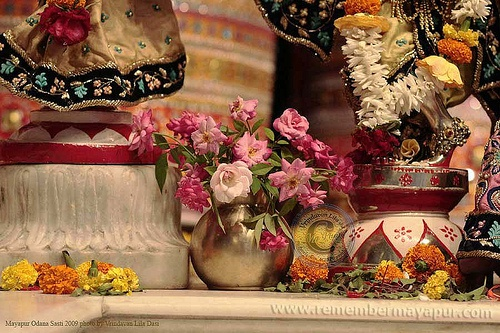Describe the objects in this image and their specific colors. I can see potted plant in maroon, brown, black, and salmon tones, vase in maroon, black, tan, and gray tones, and vase in maroon, tan, and gray tones in this image. 